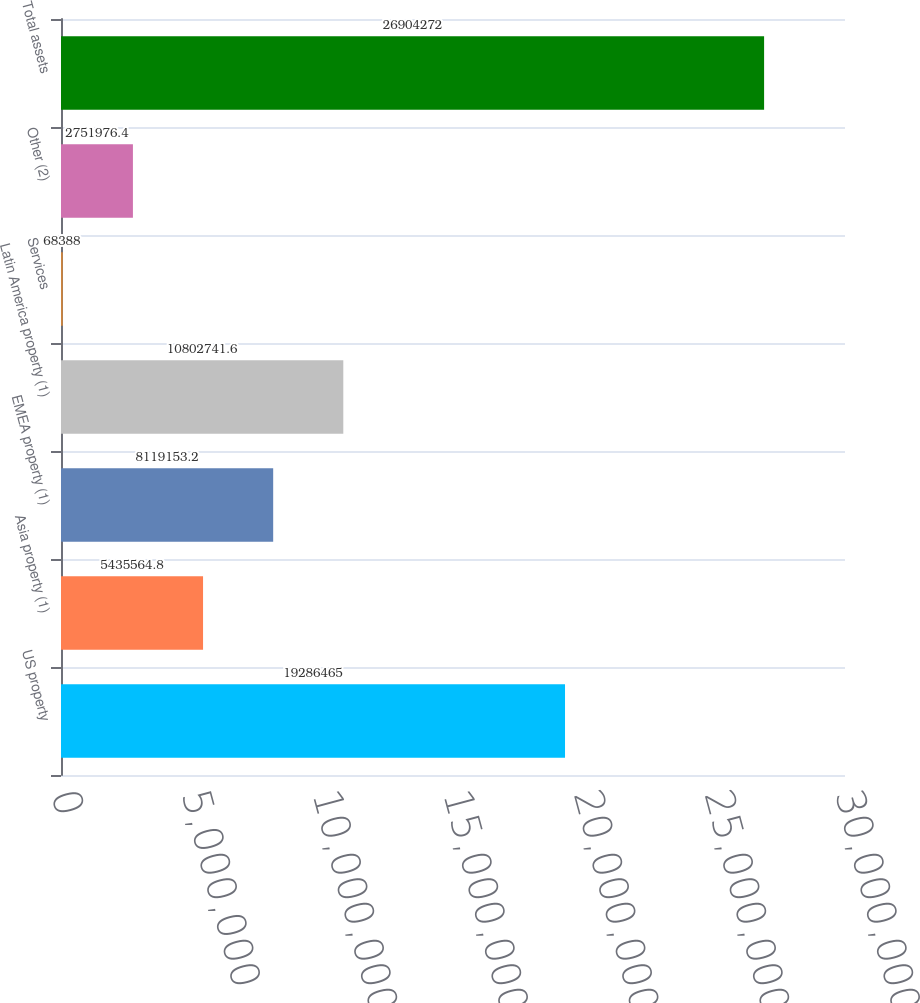Convert chart. <chart><loc_0><loc_0><loc_500><loc_500><bar_chart><fcel>US property<fcel>Asia property (1)<fcel>EMEA property (1)<fcel>Latin America property (1)<fcel>Services<fcel>Other (2)<fcel>Total assets<nl><fcel>1.92865e+07<fcel>5.43556e+06<fcel>8.11915e+06<fcel>1.08027e+07<fcel>68388<fcel>2.75198e+06<fcel>2.69043e+07<nl></chart> 